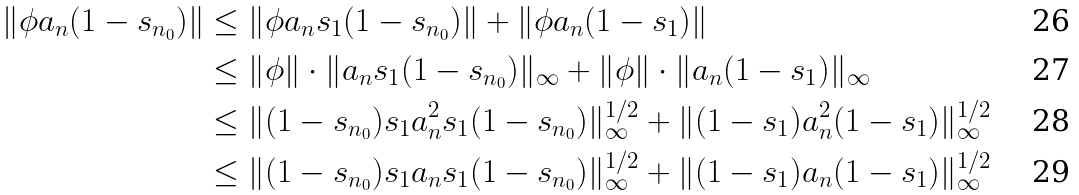<formula> <loc_0><loc_0><loc_500><loc_500>\| \phi a _ { n } ( 1 - s _ { n _ { 0 } } ) \| & \leq \| \phi a _ { n } s _ { 1 } ( 1 - s _ { n _ { 0 } } ) \| + \| \phi a _ { n } ( 1 - s _ { 1 } ) \| \\ & \leq \| \phi \| \cdot \| a _ { n } s _ { 1 } ( 1 - s _ { n _ { 0 } } ) \| _ { \infty } + \| \phi \| \cdot \| a _ { n } ( 1 - s _ { 1 } ) \| _ { \infty } \\ & \leq \| ( 1 - s _ { n _ { 0 } } ) s _ { 1 } a _ { n } ^ { 2 } s _ { 1 } ( 1 - s _ { n _ { 0 } } ) \| _ { \infty } ^ { 1 / 2 } + \| ( 1 - s _ { 1 } ) a _ { n } ^ { 2 } ( 1 - s _ { 1 } ) \| _ { \infty } ^ { 1 / 2 } \\ & \leq \| ( 1 - s _ { n _ { 0 } } ) s _ { 1 } a _ { n } s _ { 1 } ( 1 - s _ { n _ { 0 } } ) \| _ { \infty } ^ { 1 / 2 } + \| ( 1 - s _ { 1 } ) a _ { n } ( 1 - s _ { 1 } ) \| _ { \infty } ^ { 1 / 2 }</formula> 